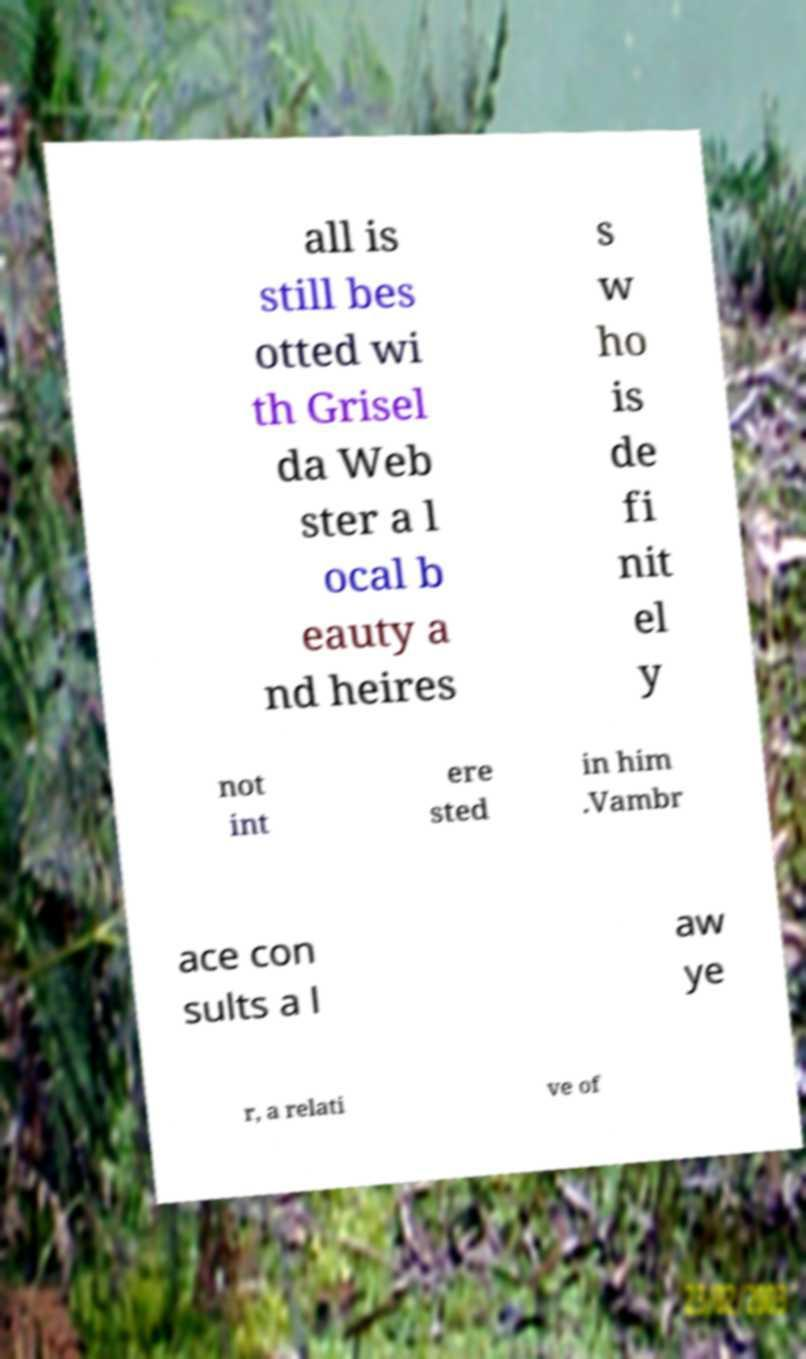Please identify and transcribe the text found in this image. all is still bes otted wi th Grisel da Web ster a l ocal b eauty a nd heires s w ho is de fi nit el y not int ere sted in him .Vambr ace con sults a l aw ye r, a relati ve of 